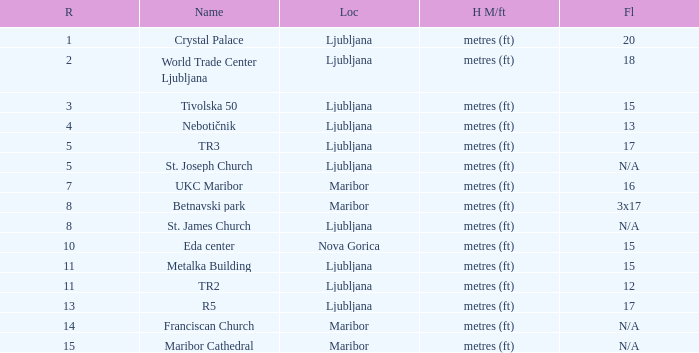Which Name has a Location of ljubljana? Crystal Palace, World Trade Center Ljubljana, Tivolska 50, Nebotičnik, TR3, St. Joseph Church, St. James Church, Metalka Building, TR2, R5. 